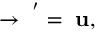<formula> <loc_0><loc_0><loc_500><loc_500>{ \Psi } \rightarrow { \Psi } ^ { ^ { \prime } } = { \Psi } { u } ,</formula> 